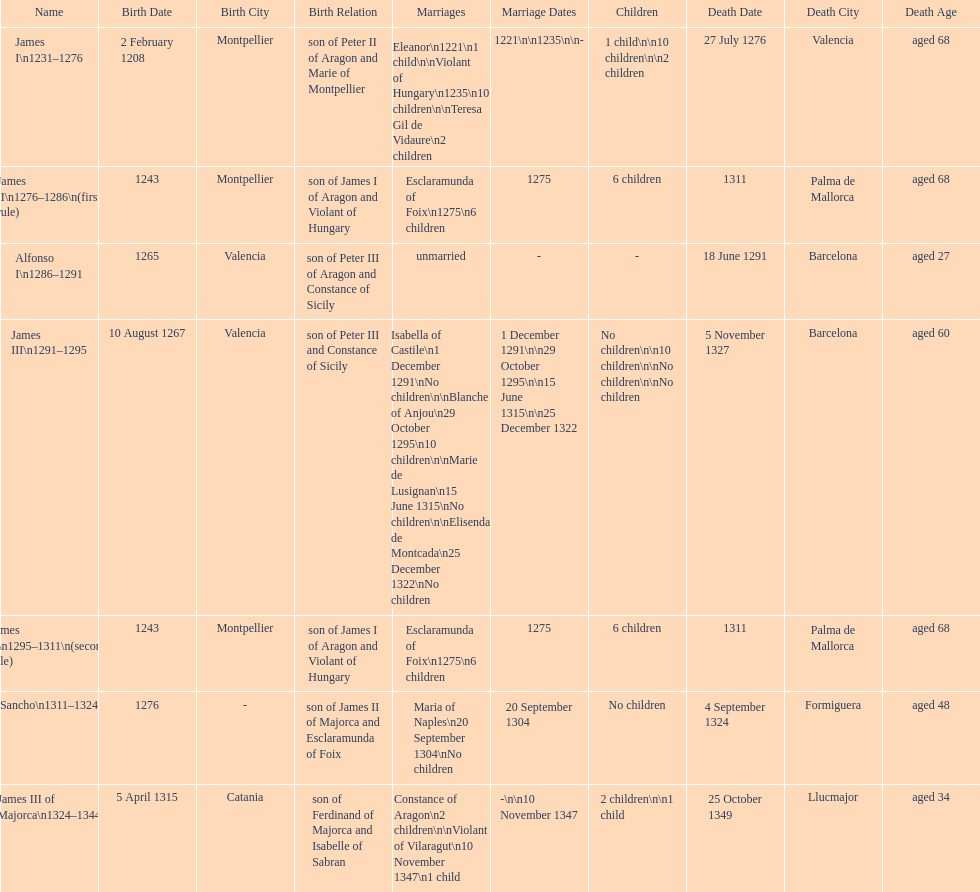Was james iii or sancho born in the year 1276? Sancho. 